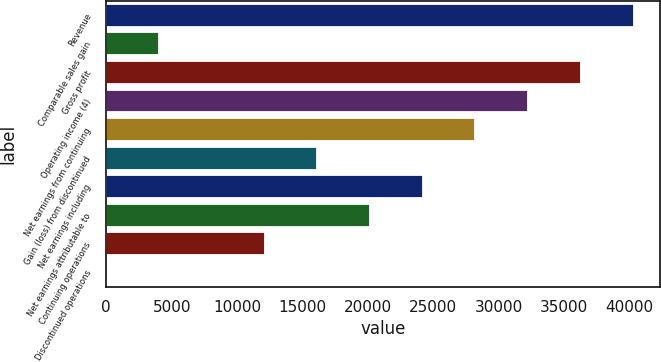Convert chart. <chart><loc_0><loc_0><loc_500><loc_500><bar_chart><fcel>Revenue<fcel>Comparable sales gain<fcel>Gross profit<fcel>Operating income (4)<fcel>Net earnings from continuing<fcel>Gain (loss) from discontinued<fcel>Net earnings including<fcel>Net earnings attributable to<fcel>Continuing operations<fcel>Discontinued operations<nl><fcel>40339<fcel>4033.94<fcel>36305.1<fcel>32271.2<fcel>28237.3<fcel>16135.6<fcel>24203.4<fcel>20169.5<fcel>12101.7<fcel>0.04<nl></chart> 